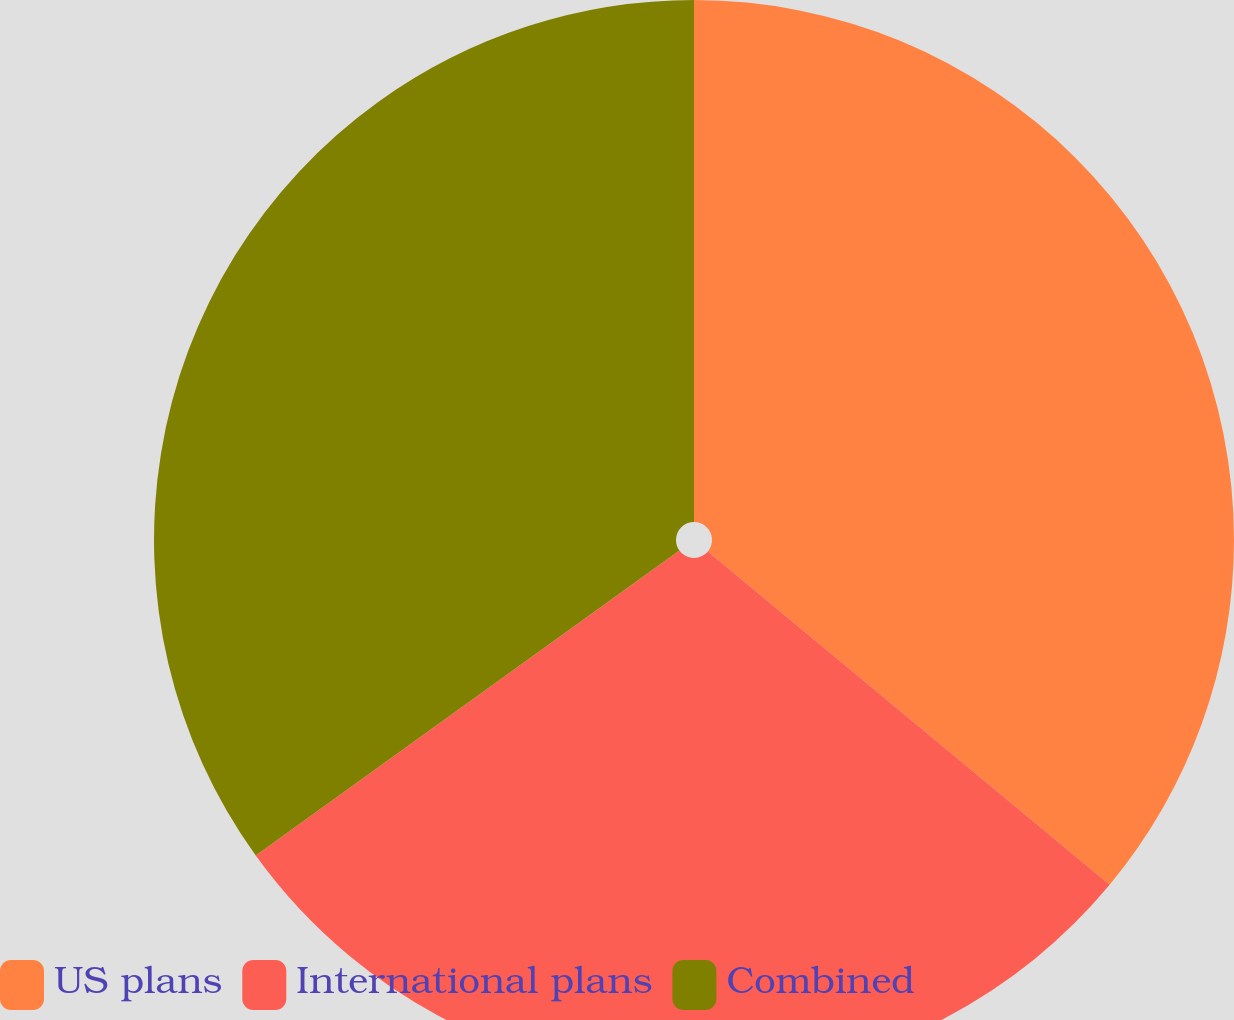Convert chart to OTSL. <chart><loc_0><loc_0><loc_500><loc_500><pie_chart><fcel>US plans<fcel>International plans<fcel>Combined<nl><fcel>36.02%<fcel>29.05%<fcel>34.93%<nl></chart> 